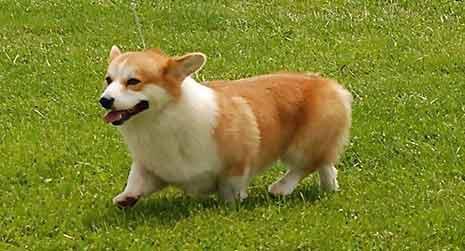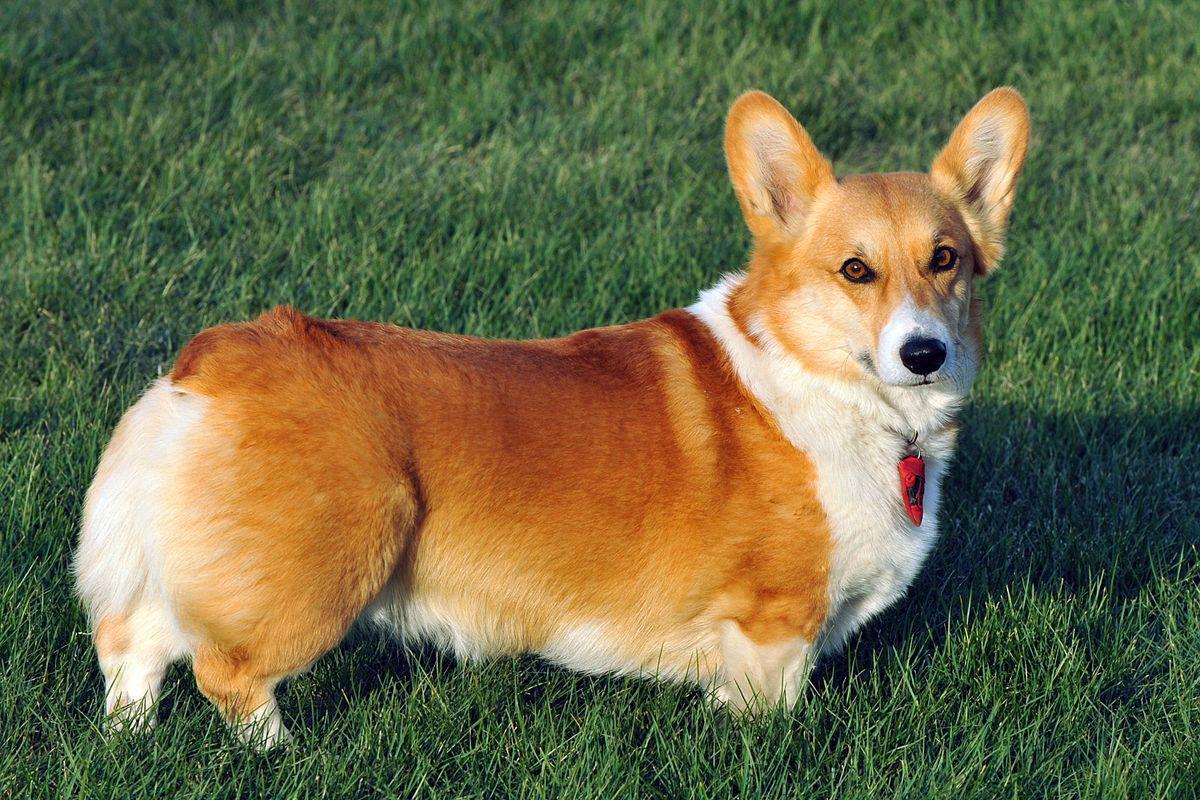The first image is the image on the left, the second image is the image on the right. For the images displayed, is the sentence "The entire dog is visible in the image on the left." factually correct? Answer yes or no. Yes. 